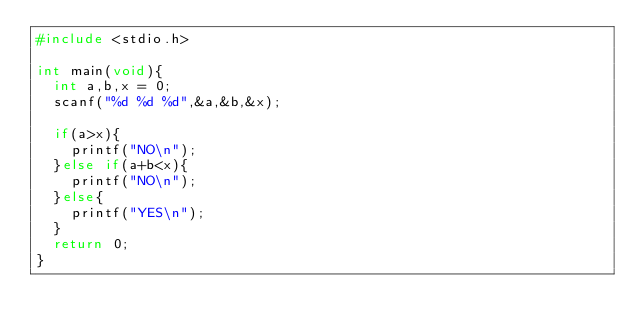Convert code to text. <code><loc_0><loc_0><loc_500><loc_500><_C_>#include <stdio.h>

int main(void){
  int a,b,x = 0;
  scanf("%d %d %d",&a,&b,&x);

  if(a>x){
    printf("NO\n");
  }else if(a+b<x){
    printf("NO\n");
  }else{
    printf("YES\n");
  }
  return 0;
}
</code> 